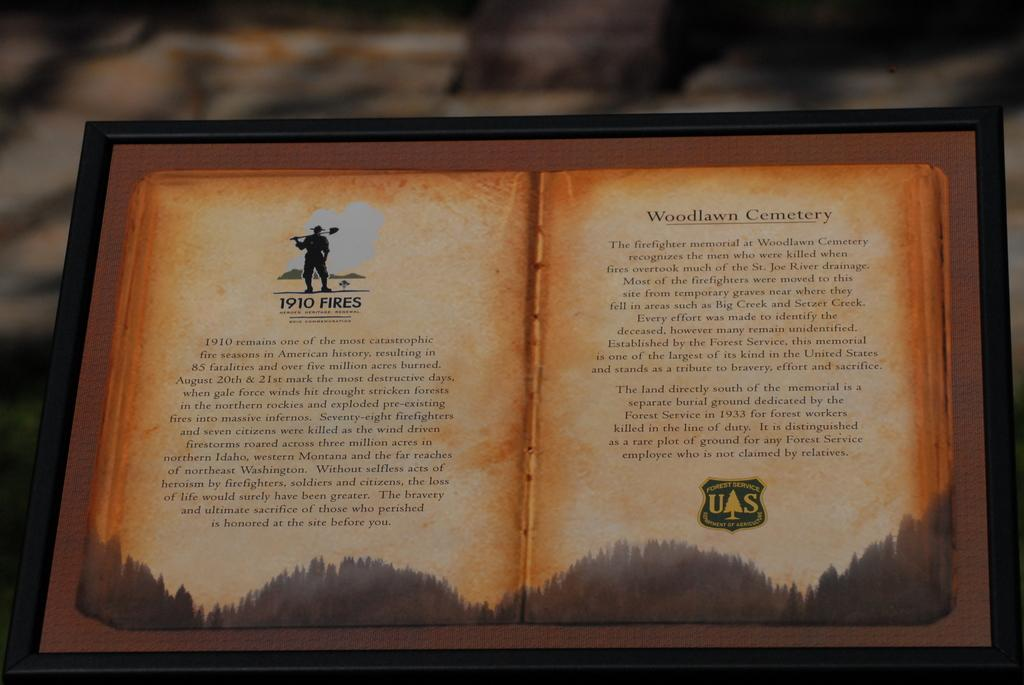<image>
Write a terse but informative summary of the picture. Open book about  1910 fires and Woodlawn Cemetary. 